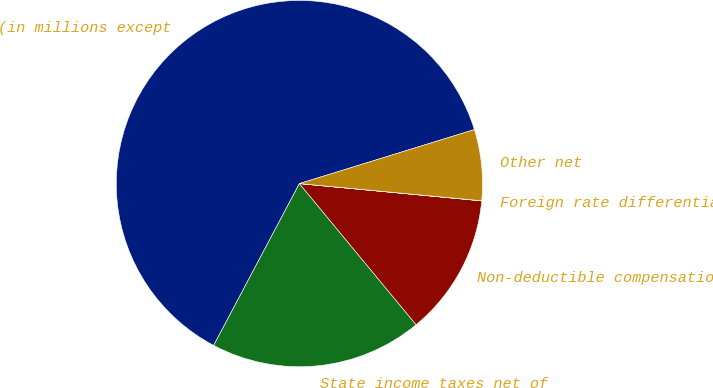Convert chart. <chart><loc_0><loc_0><loc_500><loc_500><pie_chart><fcel>(in millions except<fcel>State income taxes net of<fcel>Non-deductible compensation<fcel>Foreign rate differential<fcel>Other net<nl><fcel>62.48%<fcel>18.75%<fcel>12.5%<fcel>0.01%<fcel>6.26%<nl></chart> 